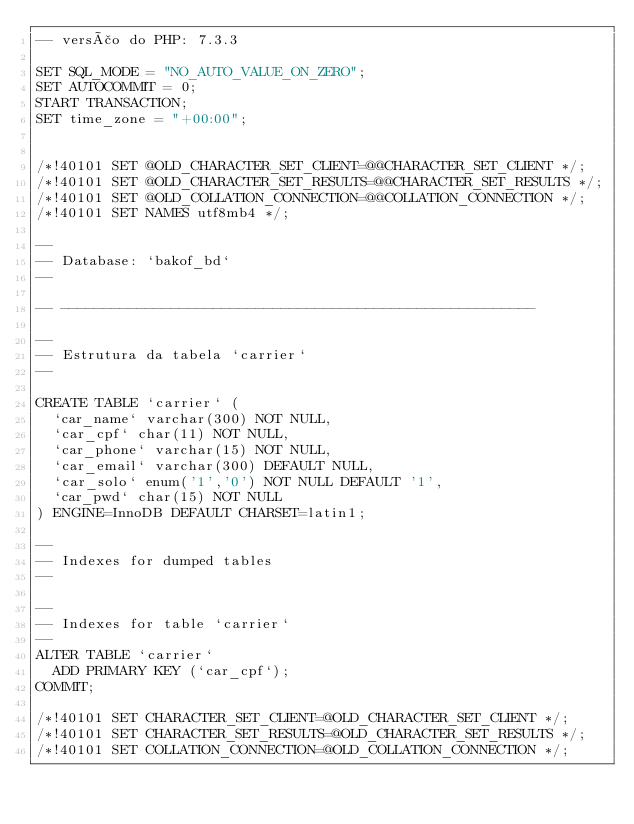Convert code to text. <code><loc_0><loc_0><loc_500><loc_500><_SQL_>-- versão do PHP: 7.3.3

SET SQL_MODE = "NO_AUTO_VALUE_ON_ZERO";
SET AUTOCOMMIT = 0;
START TRANSACTION;
SET time_zone = "+00:00";


/*!40101 SET @OLD_CHARACTER_SET_CLIENT=@@CHARACTER_SET_CLIENT */;
/*!40101 SET @OLD_CHARACTER_SET_RESULTS=@@CHARACTER_SET_RESULTS */;
/*!40101 SET @OLD_COLLATION_CONNECTION=@@COLLATION_CONNECTION */;
/*!40101 SET NAMES utf8mb4 */;

--
-- Database: `bakof_bd`
--

-- --------------------------------------------------------

--
-- Estrutura da tabela `carrier`
--

CREATE TABLE `carrier` (
  `car_name` varchar(300) NOT NULL,
  `car_cpf` char(11) NOT NULL,
  `car_phone` varchar(15) NOT NULL,
  `car_email` varchar(300) DEFAULT NULL,
  `car_solo` enum('1','0') NOT NULL DEFAULT '1',
  `car_pwd` char(15) NOT NULL
) ENGINE=InnoDB DEFAULT CHARSET=latin1;

--
-- Indexes for dumped tables
--

--
-- Indexes for table `carrier`
--
ALTER TABLE `carrier`
  ADD PRIMARY KEY (`car_cpf`);
COMMIT;

/*!40101 SET CHARACTER_SET_CLIENT=@OLD_CHARACTER_SET_CLIENT */;
/*!40101 SET CHARACTER_SET_RESULTS=@OLD_CHARACTER_SET_RESULTS */;
/*!40101 SET COLLATION_CONNECTION=@OLD_COLLATION_CONNECTION */;
</code> 